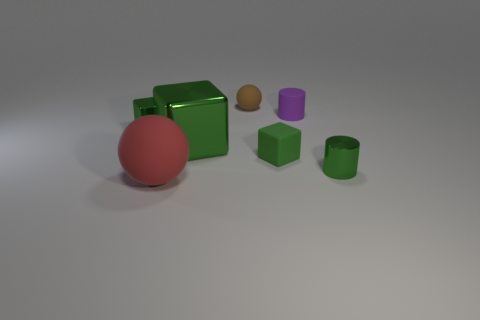How many other objects are the same material as the big green block? Upon examining the image, it appears that along with the big green block, there are two other objects that seem to share the same matte material finish - the smaller green cube and the green cylinder. So there are 2 objects made of the same material as the big green block. 